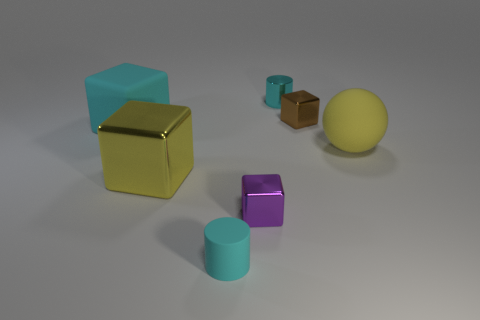The other tiny object that is the same shape as the small purple metallic object is what color?
Keep it short and to the point. Brown. What color is the large object that is made of the same material as the purple cube?
Your response must be concise. Yellow. Are there an equal number of big yellow rubber balls to the left of the yellow ball and small blocks?
Your response must be concise. No. There is a cyan cylinder to the left of the purple block; is it the same size as the tiny brown object?
Your answer should be compact. Yes. There is a rubber cube that is the same size as the yellow matte ball; what color is it?
Your answer should be compact. Cyan. There is a large rubber thing that is on the right side of the small cylinder behind the small brown metallic cube; are there any tiny shiny cubes behind it?
Provide a short and direct response. Yes. What material is the big yellow thing that is to the right of the tiny cyan rubber object?
Make the answer very short. Rubber. There is a large cyan thing; does it have the same shape as the yellow thing that is to the right of the purple metallic cube?
Your response must be concise. No. Are there the same number of cyan matte cubes that are behind the big rubber block and big blocks that are on the right side of the purple thing?
Offer a terse response. Yes. How many other objects are there of the same material as the large cyan block?
Ensure brevity in your answer.  2. 